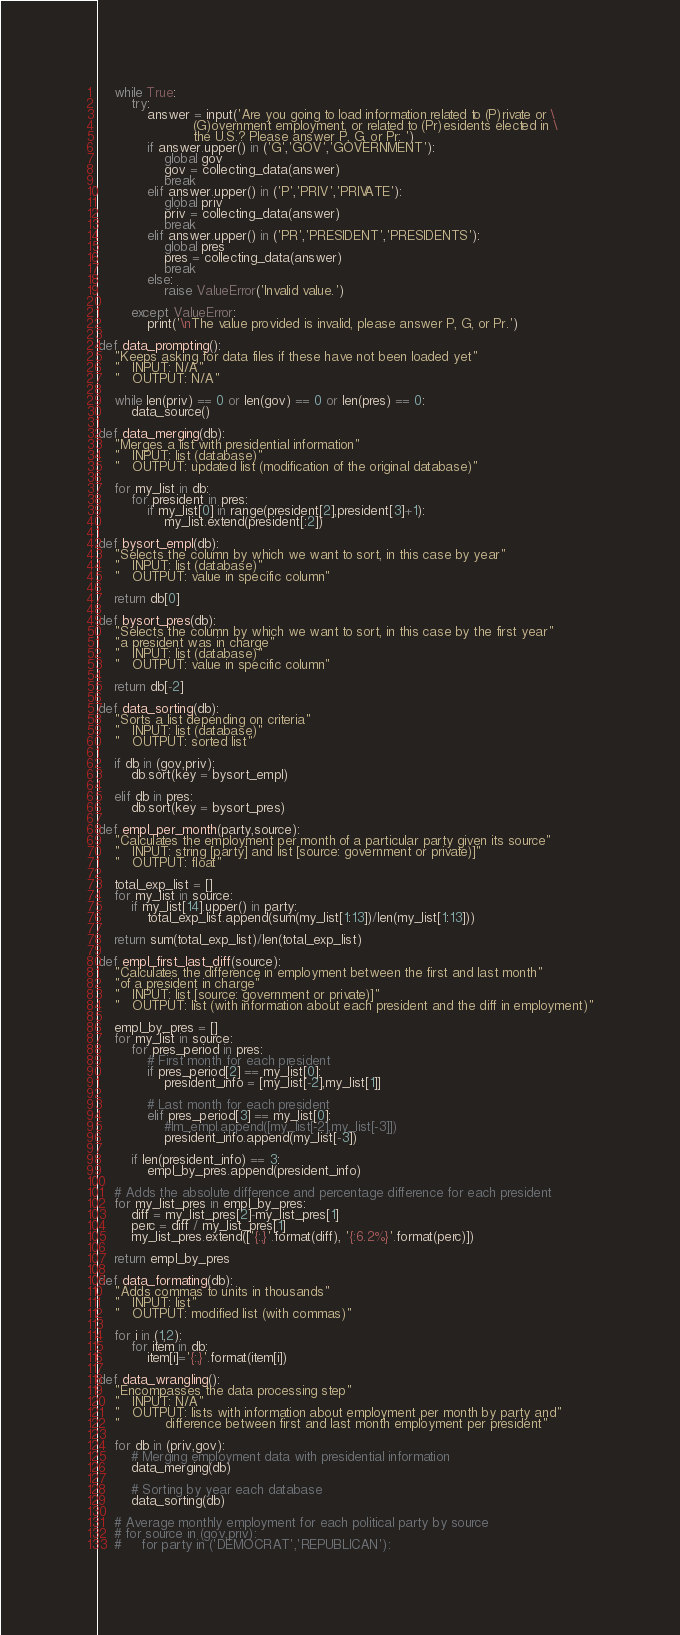<code> <loc_0><loc_0><loc_500><loc_500><_Python_>
    while True:
        try:
            answer = input('Are you going to load information related to (P)rivate or \
                       (G)overnment employment, or related to (Pr)esidents elected in \
                       the U.S.? Please answer P, G, or Pr: ')
            if answer.upper() in ('G','GOV','GOVERNMENT'):
                global gov
                gov = collecting_data(answer)
                break
            elif answer.upper() in ('P','PRIV','PRIVATE'):
                global priv
                priv = collecting_data(answer)
                break
            elif answer.upper() in ('PR','PRESIDENT','PRESIDENTS'):
                global pres
                pres = collecting_data(answer)
                break
            else:
                raise ValueError('Invalid value.')

        except ValueError:
            print('\nThe value provided is invalid, please answer P, G, or Pr.')

def data_prompting():
    "Keeps asking for data files if these have not been loaded yet"
    "   INPUT: N/A"
    "   OUTPUT: N/A"

    while len(priv) == 0 or len(gov) == 0 or len(pres) == 0:
        data_source()

def data_merging(db):
    "Merges a list with presidential information"
    "   INPUT: list (database)"
    "   OUTPUT: updated list (modification of the original database)"

    for my_list in db:
        for president in pres:
            if my_list[0] in range(president[2],president[3]+1):
                my_list.extend(president[:2])

def bysort_empl(db):
    "Selects the column by which we want to sort, in this case by year"
    "   INPUT: list (database)"
    "   OUTPUT: value in specific column"

    return db[0]

def bysort_pres(db):
    "Selects the column by which we want to sort, in this case by the first year"
    "a president was in charge"
    "   INPUT: list (database)"
    "   OUTPUT: value in specific column"

    return db[-2]

def data_sorting(db):
    "Sorts a list depending on criteria"
    "   INPUT: list (database)"
    "   OUTPUT: sorted list"

    if db in (gov,priv):
        db.sort(key = bysort_empl)

    elif db in pres:
        db.sort(key = bysort_pres)

def empl_per_month(party,source):
    "Calculates the employment per month of a particular party given its source"
    "   INPUT: string [party] and list [source: government or private)]"
    "   OUTPUT: float"

    total_exp_list = []
    for my_list in source:
        if my_list[14].upper() in party:
            total_exp_list.append(sum(my_list[1:13])/len(my_list[1:13]))

    return sum(total_exp_list)/len(total_exp_list)

def empl_first_last_diff(source):
    "Calculates the difference in employment between the first and last month"
    "of a president in charge"
    "   INPUT: list [source: government or private)]"
    "   OUTPUT: list (with information about each president and the diff in employment)"

    empl_by_pres = []
    for my_list in source:
        for pres_period in pres:
            # First month for each president
            if pres_period[2] == my_list[0]:
                president_info = [my_list[-2],my_list[1]]

            # Last month for each president
            elif pres_period[3] == my_list[0]:
                #lm_empl.append([my_list[-2],my_list[-3]])
                president_info.append(my_list[-3])

        if len(president_info) == 3:
            empl_by_pres.append(president_info)

    # Adds the absolute difference and percentage difference for each president
    for my_list_pres in empl_by_pres:
        diff = my_list_pres[2]-my_list_pres[1]
        perc = diff / my_list_pres[1]
        my_list_pres.extend(['{:,}'.format(diff), '{:6.2%}'.format(perc)])

    return empl_by_pres

def data_formating(db):
    "Adds commas to units in thousands"
    "   INPUT: list"
    "   OUTPUT: modified list (with commas)"

    for i in (1,2):
        for item in db:
            item[i]='{:,}'.format(item[i])

def data_wrangling():
    "Encompasses the data processing step"
    "   INPUT: N/A"
    "   OUTPUT: lists with information about employment per month by party and"
    "           difference between first and last month employment per president"

    for db in (priv,gov):
        # Merging employment data with presidential information
        data_merging(db)

        # Sorting by year each database
        data_sorting(db)

    # Average monthly employment for each political party by source
    # for source in (gov,priv):
    #     for party in ('DEMOCRAT','REPUBLICAN'):</code> 